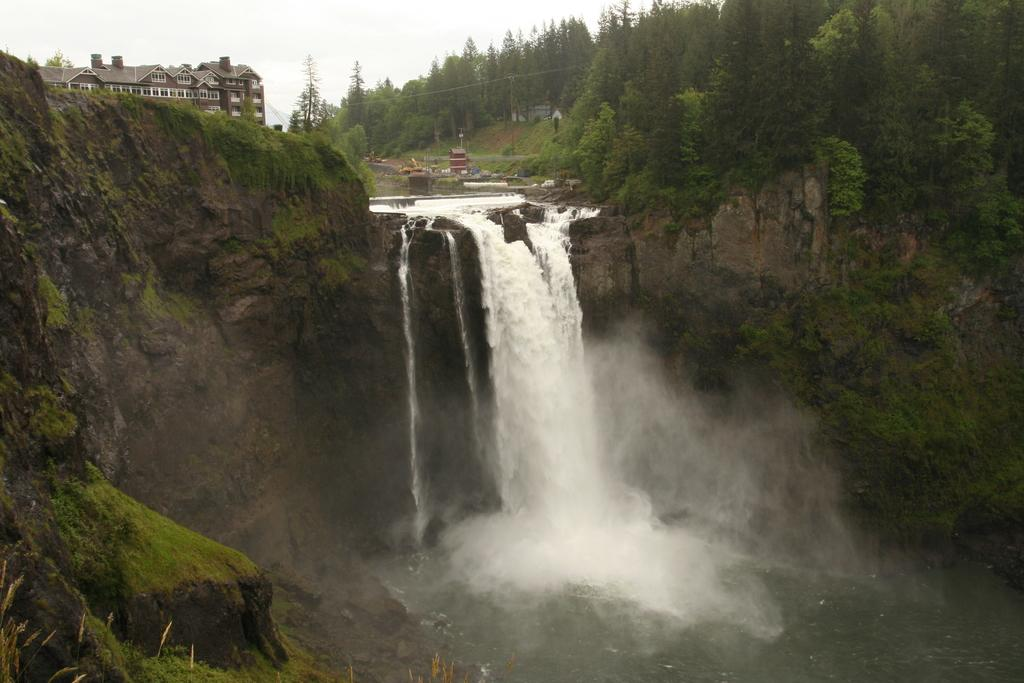What natural feature is present in the image? There is a waterfall in the image. What man-made structures can be seen in the image? There are buildings in the image. What type of vegetation is present in the image? There are trees in the image. What geographical feature is present in the image? There are hills in the image. What is visible in the background of the image? The sky is visible in the background of the image. Can you hear the goat singing a song in the image? There is no goat or song present in the image; it features a waterfall, buildings, trees, hills, and the sky. 